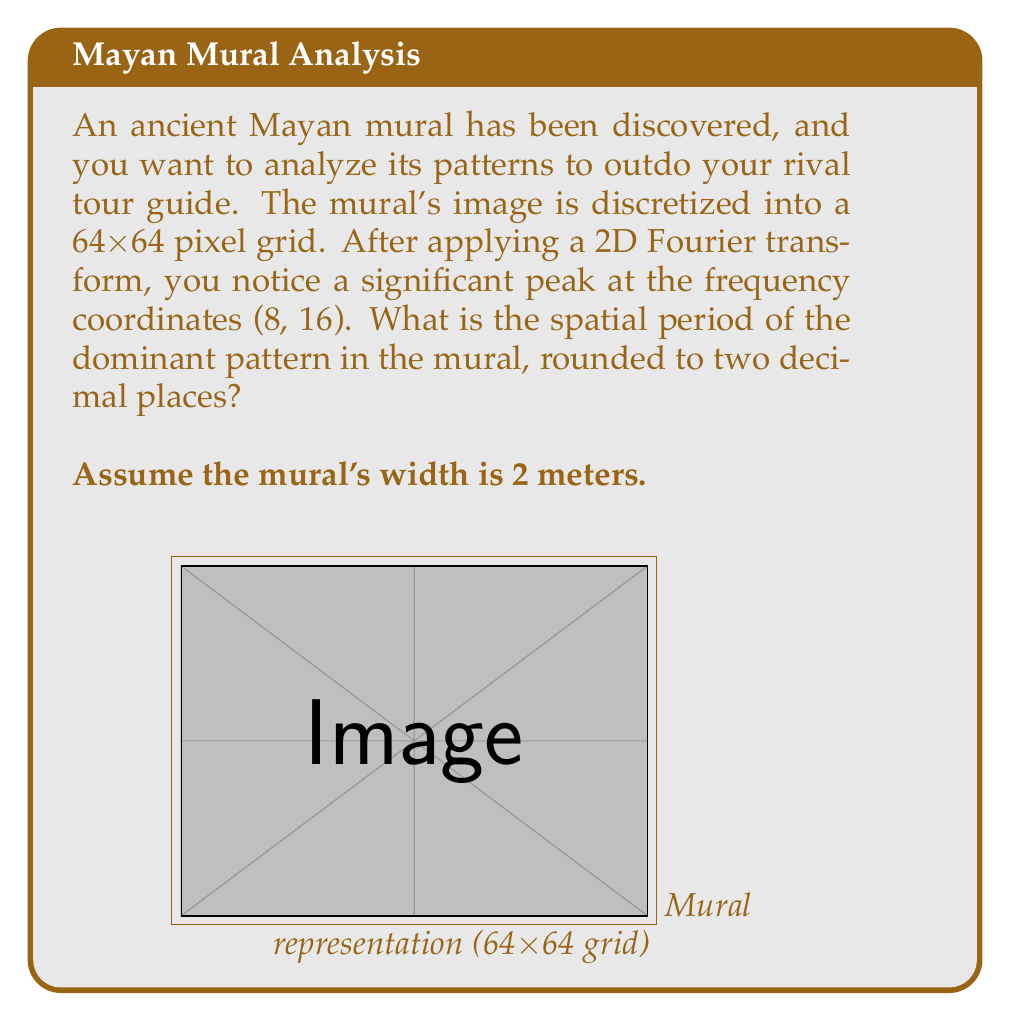Give your solution to this math problem. Let's approach this step-by-step:

1) In a discrete Fourier transform of an NxN image, the frequency coordinates (u, v) correspond to spatial frequencies of u cycles per N pixels in the x-direction and v cycles per N pixels in the y-direction.

2) Here, N = 64 and we have a peak at (8, 16). This means:
   - 8 cycles per 64 pixels in x-direction
   - 16 cycles per 64 pixels in y-direction

3) The dominant frequency is the one with more cycles, which is 16 cycles per 64 pixels in the y-direction.

4) To find the spatial period, we need to:
   a) Find how many pixels correspond to one cycle
   b) Convert this to meters

5) Pixels per cycle:
   $$ \text{Pixels per cycle} = \frac{64 \text{ pixels}}{16 \text{ cycles}} = 4 \text{ pixels/cycle} $$

6) The mural is 2 meters wide and represented by 64 pixels, so each pixel represents:
   $$ \text{Meters per pixel} = \frac{2 \text{ meters}}{64 \text{ pixels}} = 0.03125 \text{ meters/pixel} $$

7) Therefore, the spatial period in meters is:
   $$ \text{Spatial period} = 4 \text{ pixels/cycle} \times 0.03125 \text{ meters/pixel} = 0.125 \text{ meters/cycle} $$

8) Rounding to two decimal places: 0.13 meters.
Answer: 0.13 meters 